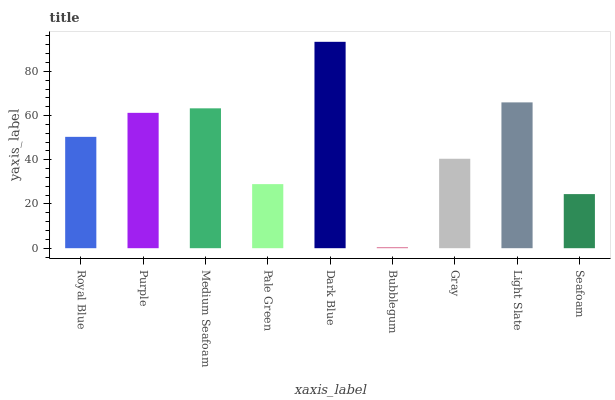Is Bubblegum the minimum?
Answer yes or no. Yes. Is Dark Blue the maximum?
Answer yes or no. Yes. Is Purple the minimum?
Answer yes or no. No. Is Purple the maximum?
Answer yes or no. No. Is Purple greater than Royal Blue?
Answer yes or no. Yes. Is Royal Blue less than Purple?
Answer yes or no. Yes. Is Royal Blue greater than Purple?
Answer yes or no. No. Is Purple less than Royal Blue?
Answer yes or no. No. Is Royal Blue the high median?
Answer yes or no. Yes. Is Royal Blue the low median?
Answer yes or no. Yes. Is Dark Blue the high median?
Answer yes or no. No. Is Bubblegum the low median?
Answer yes or no. No. 